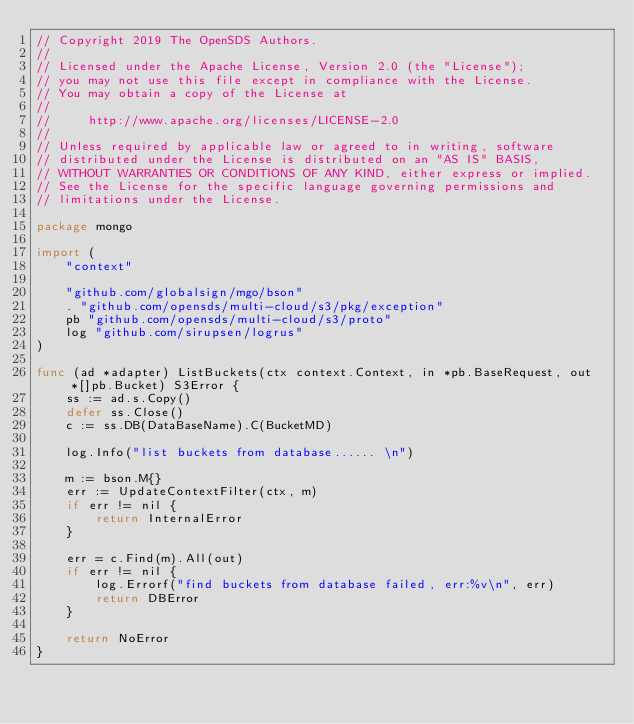<code> <loc_0><loc_0><loc_500><loc_500><_Go_>// Copyright 2019 The OpenSDS Authors.
//
// Licensed under the Apache License, Version 2.0 (the "License");
// you may not use this file except in compliance with the License.
// You may obtain a copy of the License at
//
//     http://www.apache.org/licenses/LICENSE-2.0
//
// Unless required by applicable law or agreed to in writing, software
// distributed under the License is distributed on an "AS IS" BASIS,
// WITHOUT WARRANTIES OR CONDITIONS OF ANY KIND, either express or implied.
// See the License for the specific language governing permissions and
// limitations under the License.

package mongo

import (
	"context"

	"github.com/globalsign/mgo/bson"
	. "github.com/opensds/multi-cloud/s3/pkg/exception"
	pb "github.com/opensds/multi-cloud/s3/proto"
	log "github.com/sirupsen/logrus"
)

func (ad *adapter) ListBuckets(ctx context.Context, in *pb.BaseRequest, out *[]pb.Bucket) S3Error {
	ss := ad.s.Copy()
	defer ss.Close()
	c := ss.DB(DataBaseName).C(BucketMD)

	log.Info("list buckets from database...... \n")

	m := bson.M{}
	err := UpdateContextFilter(ctx, m)
	if err != nil {
		return InternalError
	}

	err = c.Find(m).All(out)
	if err != nil {
		log.Errorf("find buckets from database failed, err:%v\n", err)
		return DBError
	}

	return NoError
}
</code> 